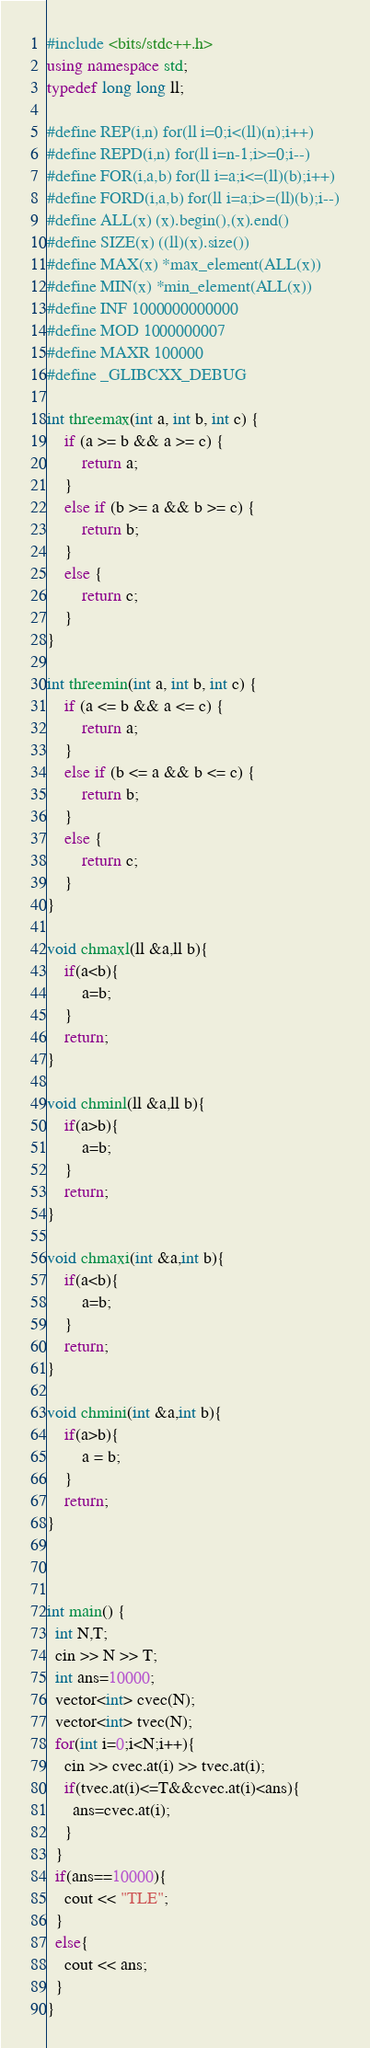Convert code to text. <code><loc_0><loc_0><loc_500><loc_500><_C++_>#include <bits/stdc++.h>
using namespace std;
typedef long long ll;
 
#define REP(i,n) for(ll i=0;i<(ll)(n);i++)
#define REPD(i,n) for(ll i=n-1;i>=0;i--)
#define FOR(i,a,b) for(ll i=a;i<=(ll)(b);i++)
#define FORD(i,a,b) for(ll i=a;i>=(ll)(b);i--)
#define ALL(x) (x).begin(),(x).end()
#define SIZE(x) ((ll)(x).size())
#define MAX(x) *max_element(ALL(x))
#define MIN(x) *min_element(ALL(x))
#define INF 1000000000000
#define MOD 1000000007
#define MAXR 100000
#define _GLIBCXX_DEBUG
 
int threemax(int a, int b, int c) {
	if (a >= b && a >= c) {
		return a;
	}
	else if (b >= a && b >= c) {
		return b;
	}
	else {
		return c;
	}
}
 
int threemin(int a, int b, int c) {
	if (a <= b && a <= c) {
		return a;
	}
	else if (b <= a && b <= c) {
		return b;
	}
	else {
		return c;
	}
}
 
void chmaxl(ll &a,ll b){
	if(a<b){
		a=b;
	}
	return;
}
 
void chminl(ll &a,ll b){
	if(a>b){
		a=b;
	}
	return;
}
 
void chmaxi(int &a,int b){
	if(a<b){
		a=b;
	}
	return;
}
 
void chmini(int &a,int b){
	if(a>b){
		a = b;
	}
	return;
}
 
 
 
int main() {
  int N,T;
  cin >> N >> T;
  int ans=10000;
  vector<int> cvec(N);
  vector<int> tvec(N);
  for(int i=0;i<N;i++){
    cin >> cvec.at(i) >> tvec.at(i);
    if(tvec.at(i)<=T&&cvec.at(i)<ans){
      ans=cvec.at(i);
    }
  }
  if(ans==10000){
    cout << "TLE";
  }
  else{
    cout << ans;
  }
}</code> 